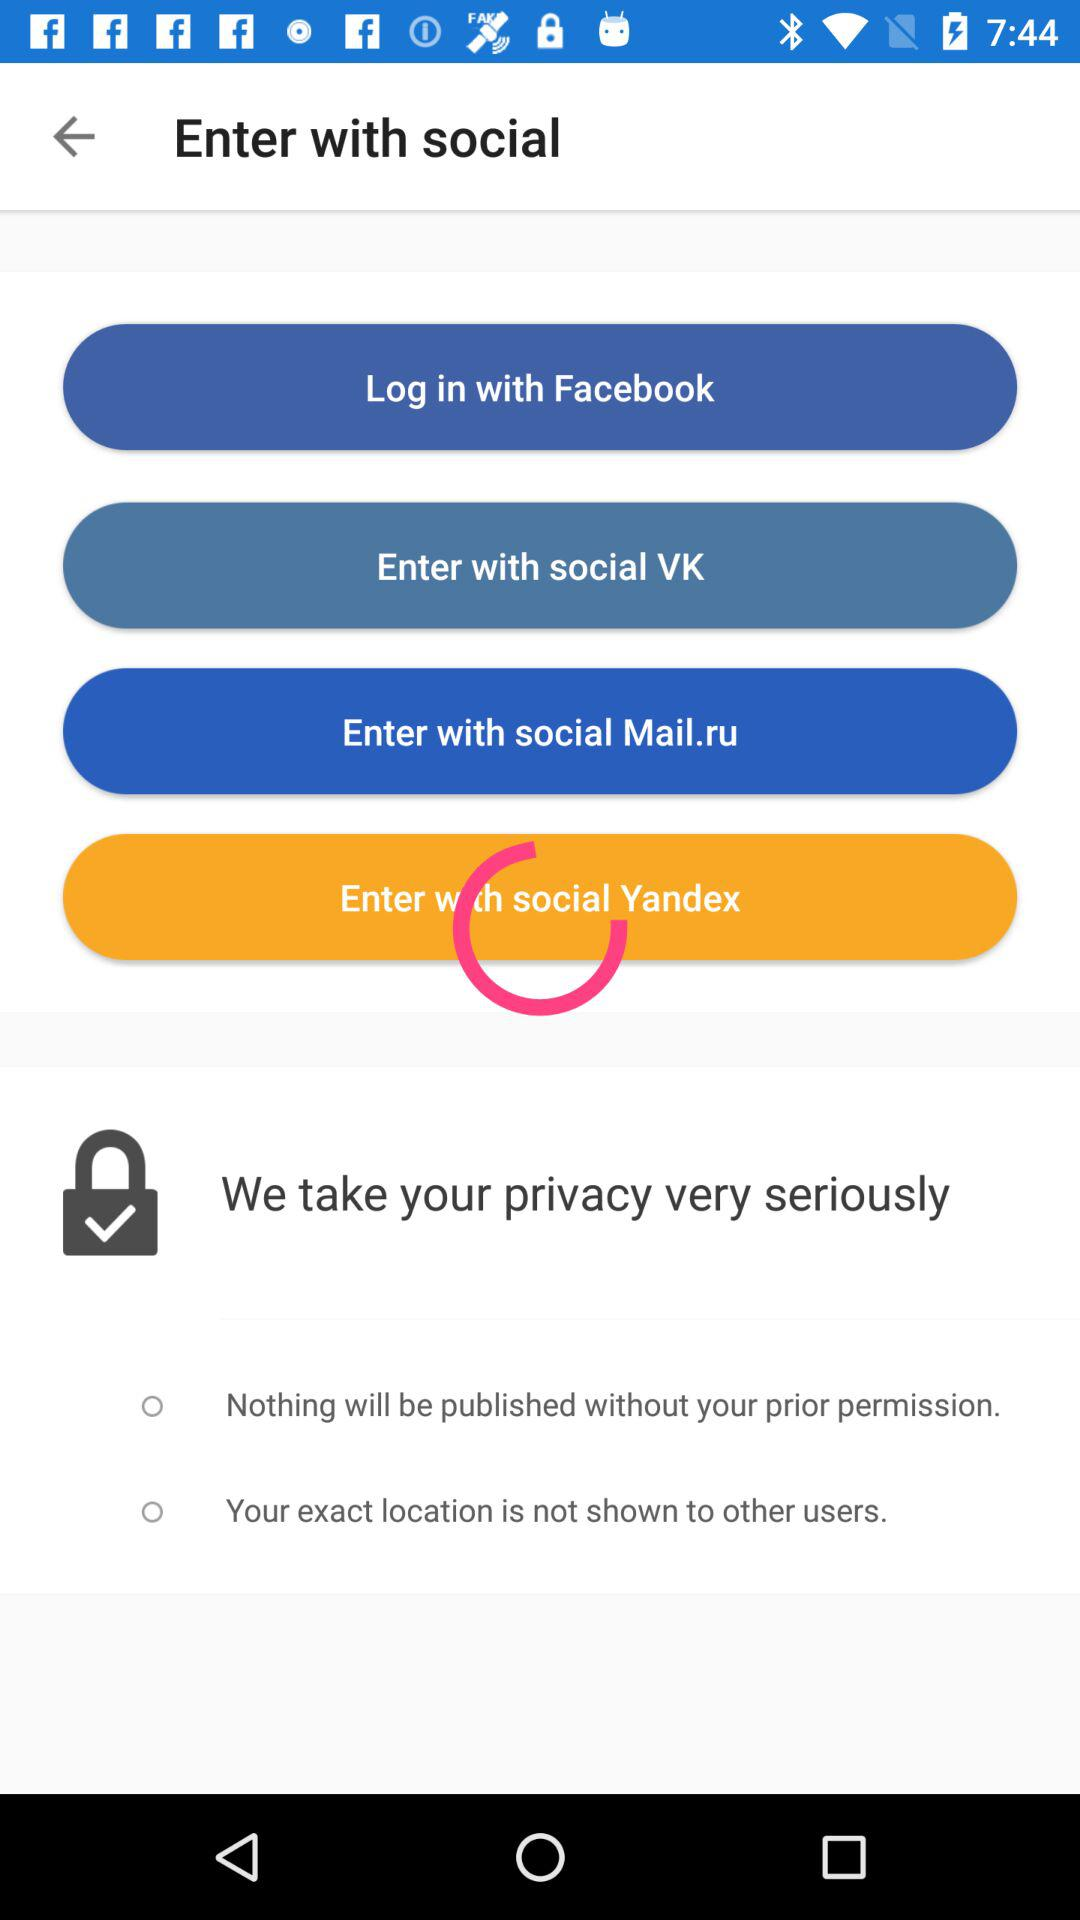How many social media options are there to log in with?
Answer the question using a single word or phrase. 4 